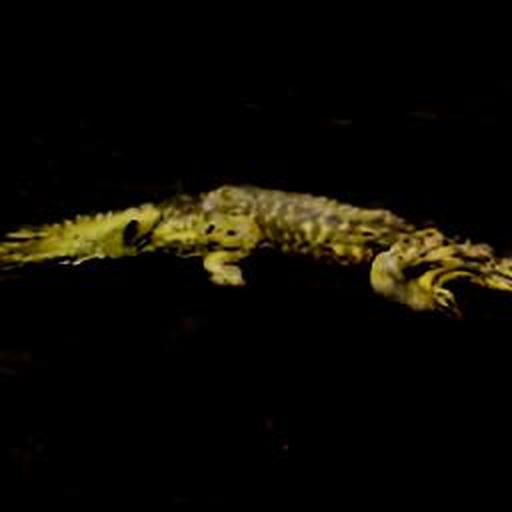What can you infer about the habitat where this creature lives? Based on the darkness and the visual cues in the image, it is likely that the crocodile's natural habitat includes murky waters or swamps with limited visibility. These environments provide ample cover and facilitate the animal's ability to surprise prey. The absence of any clearly visible aquatic plants or other animals suggests this creature might be lurking in a secluded area, waiting to hunt. What impact does this photo have from a conservationist's perspective? This photo highlights the elusive nature of the animal in its natural setting, which could be used to advocate for the preservation of such habitats. It underscores the need to protect these complex ecosystems that harbor vital biodiversity. Moreover, the mysterious aura of the image might draw public interest and support for conservation efforts. 